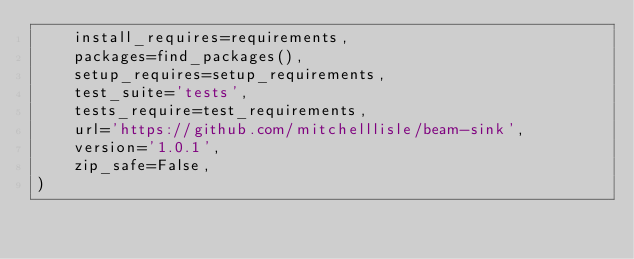Convert code to text. <code><loc_0><loc_0><loc_500><loc_500><_Python_>    install_requires=requirements,
    packages=find_packages(),
    setup_requires=setup_requirements,
    test_suite='tests',
    tests_require=test_requirements,
    url='https://github.com/mitchelllisle/beam-sink',
    version='1.0.1',
    zip_safe=False,
)
</code> 